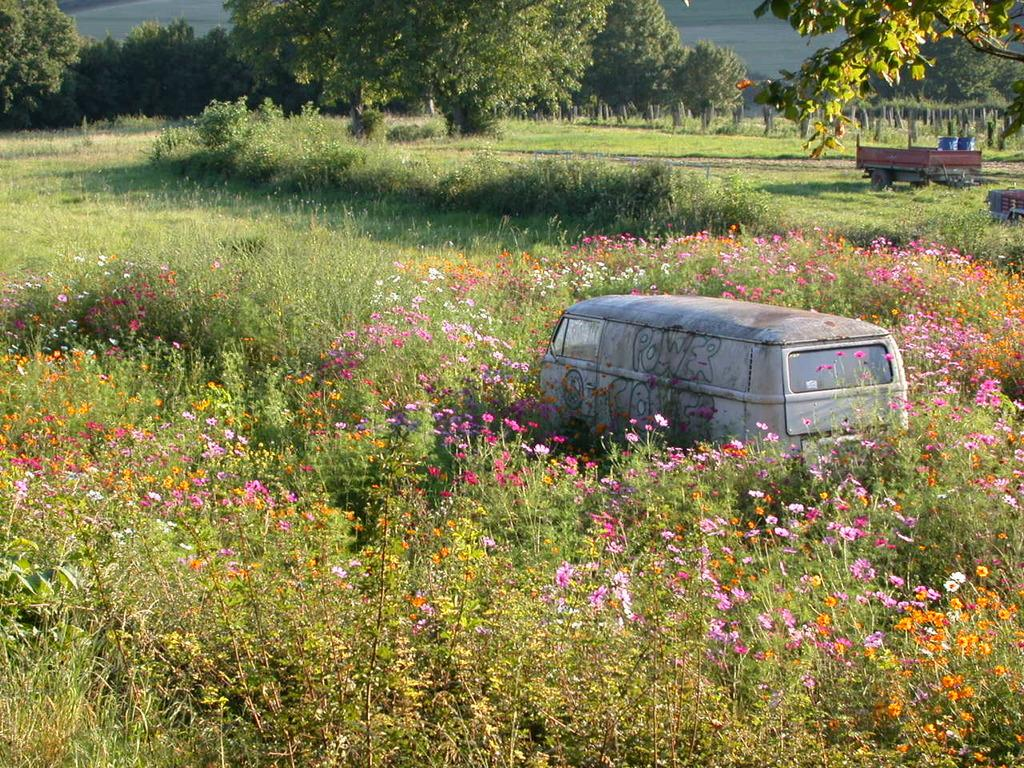Where was the image taken? The image was taken outside. What can be seen in the foreground of the image? There are plants and flowers, as well as a vehicle, in the foreground. What is visible in the background of the image? The sky, trees, plants, and vehicles can be seen in the background. What language are the pigs speaking in the image? There are no pigs present in the image, so it is not possible to determine what language they might be speaking. 